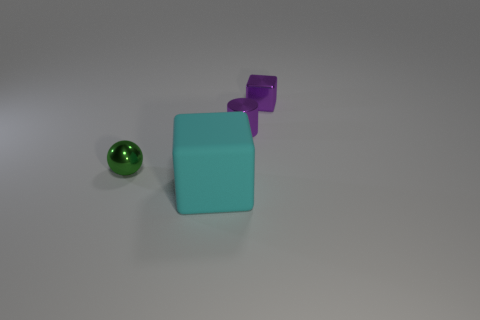Is there anything else that has the same material as the big cyan object?
Provide a succinct answer. No. The large cube is what color?
Your answer should be compact. Cyan. Are there more tiny purple cubes in front of the large cyan rubber block than green spheres in front of the green sphere?
Offer a terse response. No. There is a large cyan object; is it the same shape as the purple metal thing in front of the metallic block?
Your response must be concise. No. Do the cube that is to the right of the cyan thing and the cube that is on the left side of the tiny block have the same size?
Keep it short and to the point. No. There is a small purple metal thing on the left side of the block behind the tiny green object; is there a purple object behind it?
Your answer should be compact. Yes. Is the number of cyan rubber objects right of the large cyan thing less than the number of purple cylinders that are right of the purple cube?
Provide a succinct answer. No. There is a green thing that is made of the same material as the tiny purple cylinder; what is its shape?
Make the answer very short. Sphere. What is the size of the cube that is in front of the tiny metallic thing that is to the left of the cube in front of the tiny cube?
Your answer should be very brief. Large. Is the number of tiny blocks greater than the number of gray shiny cylinders?
Provide a short and direct response. Yes. 